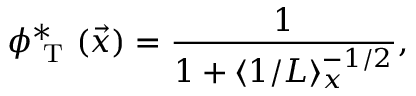Convert formula to latex. <formula><loc_0><loc_0><loc_500><loc_500>\phi _ { T } ^ { * } ( \vec { x } ) = \frac { 1 } { 1 + \langle 1 / L \rangle _ { x } ^ { - 1 / 2 } } ,</formula> 